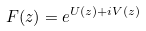Convert formula to latex. <formula><loc_0><loc_0><loc_500><loc_500>F ( z ) = e ^ { U ( z ) + i V ( z ) }</formula> 